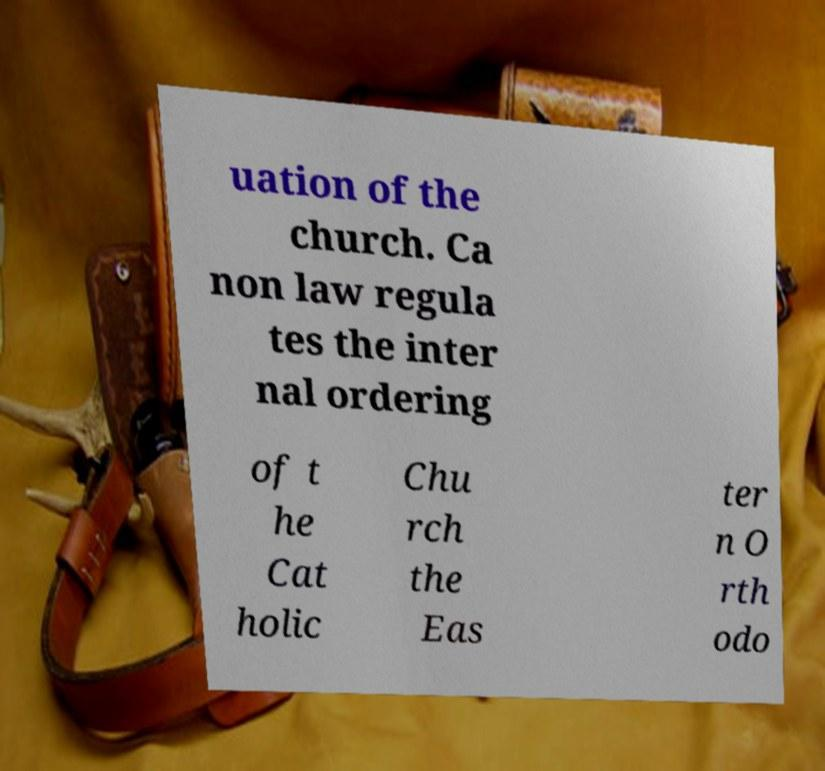Please read and relay the text visible in this image. What does it say? uation of the church. Ca non law regula tes the inter nal ordering of t he Cat holic Chu rch the Eas ter n O rth odo 